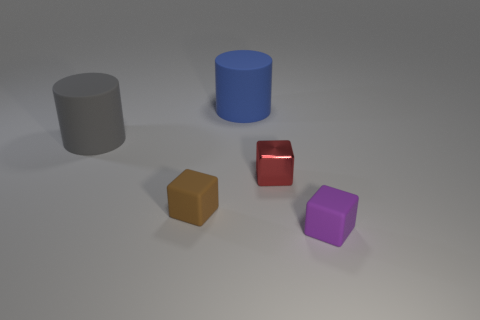What shape is the blue matte thing that is the same size as the gray matte cylinder?
Your response must be concise. Cylinder. How many things are behind the tiny brown thing and to the right of the large blue matte thing?
Your response must be concise. 1. Are there fewer blue things that are on the left side of the big gray matte object than small red shiny objects?
Provide a short and direct response. Yes. Is there another matte block that has the same size as the purple matte block?
Give a very brief answer. Yes. The other cube that is made of the same material as the brown cube is what color?
Offer a very short reply. Purple. How many cubes are left of the cylinder behind the gray matte object?
Keep it short and to the point. 1. There is a object that is both behind the small red thing and right of the gray rubber thing; what material is it?
Provide a short and direct response. Rubber. There is a matte thing to the right of the tiny metallic thing; does it have the same shape as the blue matte thing?
Your answer should be compact. No. Is the number of yellow metallic cylinders less than the number of brown objects?
Offer a terse response. Yes. Is the number of tiny red things greater than the number of small red cylinders?
Provide a succinct answer. Yes. 